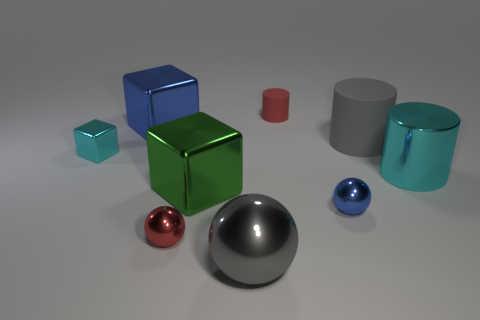What number of other metallic things have the same shape as the tiny cyan object?
Your answer should be very brief. 2. What size is the blue sphere that is the same material as the small red sphere?
Make the answer very short. Small. Do the red sphere and the cyan cylinder have the same size?
Your answer should be very brief. No. Are there any gray matte cylinders?
Ensure brevity in your answer.  Yes. There is a cylinder that is the same color as the big metal sphere; what size is it?
Keep it short and to the point. Large. There is a ball to the right of the red thing that is behind the small shiny thing right of the green block; what size is it?
Your answer should be very brief. Small. What number of cyan objects have the same material as the green object?
Your answer should be very brief. 2. What number of blue metal cubes have the same size as the cyan cube?
Provide a succinct answer. 0. What material is the tiny red thing that is on the right side of the large shiny cube in front of the gray cylinder that is left of the big cyan thing?
Your response must be concise. Rubber. What number of objects are either tiny brown cylinders or big cylinders?
Provide a succinct answer. 2. 